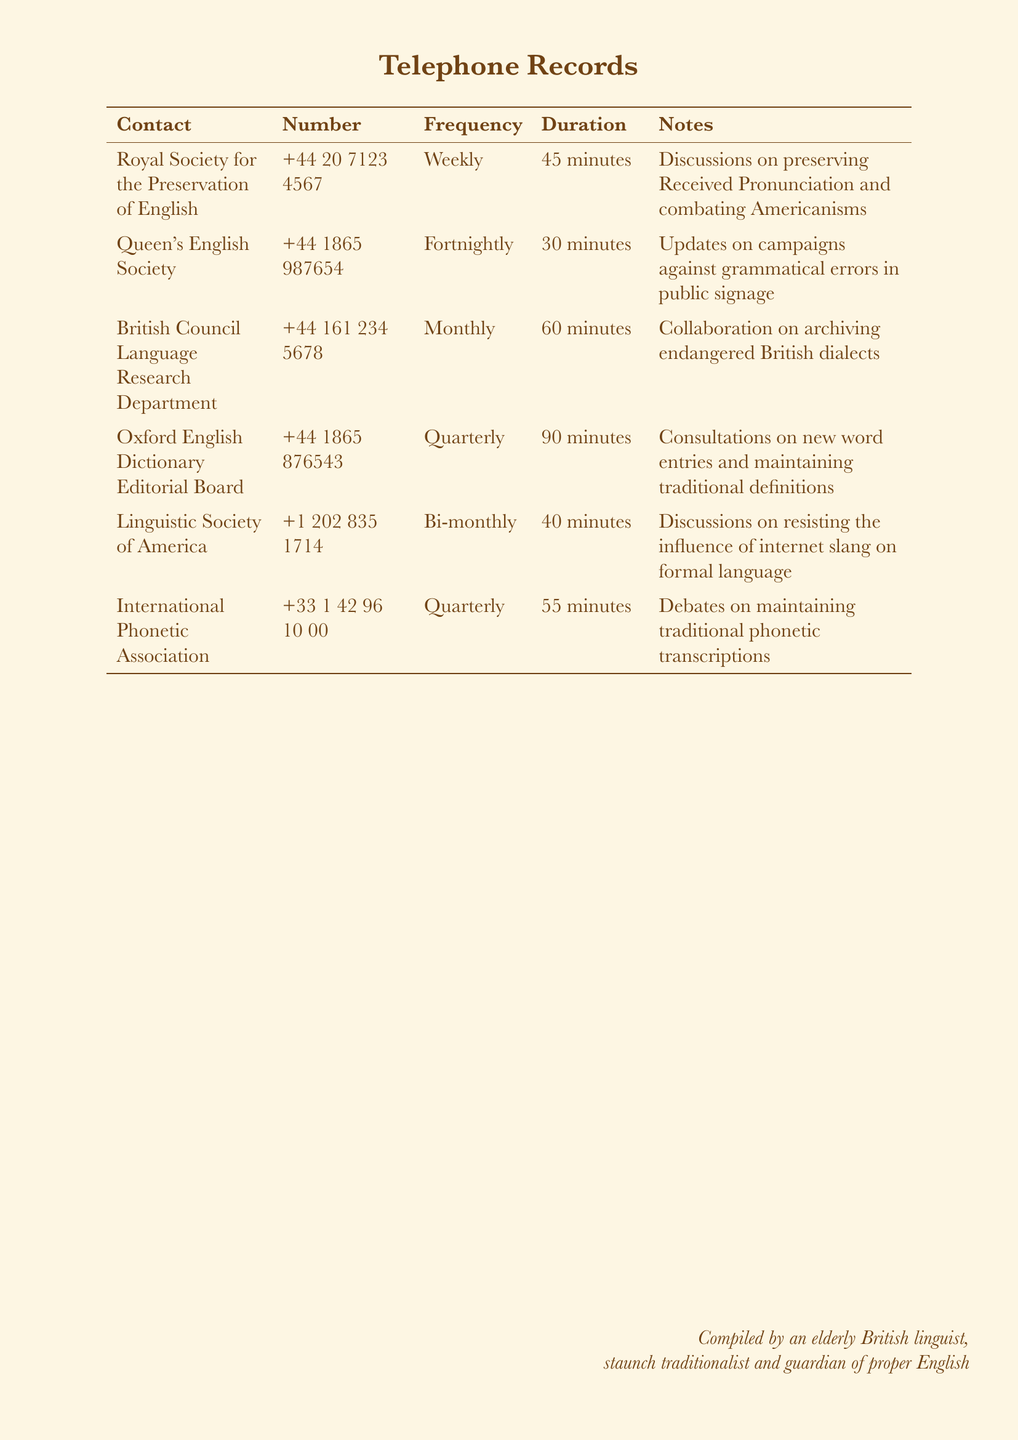what is the contact name for preserving Received Pronunciation? The contact for preserving Received Pronunciation is the Royal Society for the Preservation of English.
Answer: Royal Society for the Preservation of English how frequently does the Queen's English Society meet? The frequency of the Queen's English Society's meetings is noted in the document.
Answer: Fortnightly what is the duration of the call with the British Council Language Research Department? The document provides the duration of this particular call, which reflects the time spent discussing language preservation.
Answer: 60 minutes which society discusses resisting internet slang's influence? The document lists societies and their focus, identifying one that resists internet slang.
Answer: Linguistic Society of America how many minutes is the longest call noted in the records? The longest call duration is found by comparing all durations in the document.
Answer: 90 minutes which organization is consulted about new word entries? The relevant organization that deals with new word entries is documented clearly.
Answer: Oxford English Dictionary Editorial Board how often does the International Phonetic Association meet? This information reveals the regularity of their consultations as noted in the records.
Answer: Quarterly what type of errors does the Queen’s English Society campaign against? The document outlines the areas of concern for various societies, specifying the Queen's English Society's focus.
Answer: Grammatical errors what is the primary goal of the Royal Society for the Preservation of English? This question seeks to understand the main agenda discussed in their meetings, as noted in the document.
Answer: Preserving Received Pronunciation 